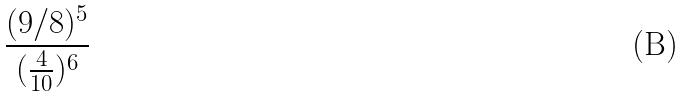Convert formula to latex. <formula><loc_0><loc_0><loc_500><loc_500>\frac { ( 9 / 8 ) ^ { 5 } } { ( \frac { 4 } { 1 0 } ) ^ { 6 } }</formula> 